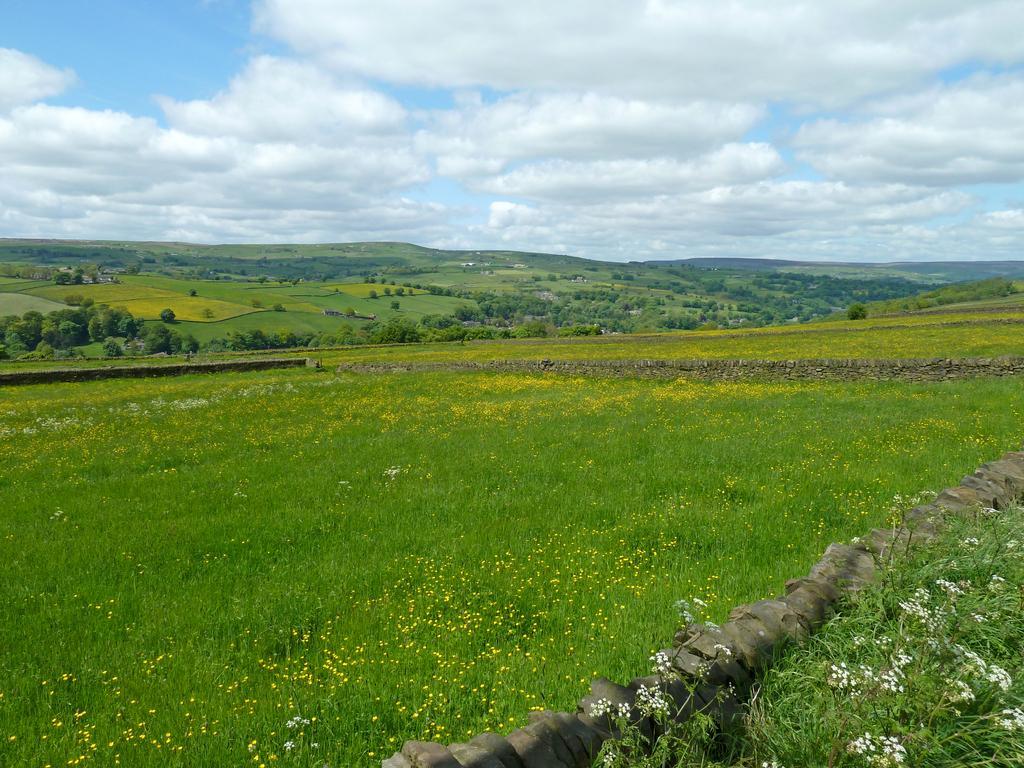Describe this image in one or two sentences. In this picture we can see grass, some plants and flowers at the bottom, in the background there are some trees, we can see the sky and clouds at the top of the picture. 